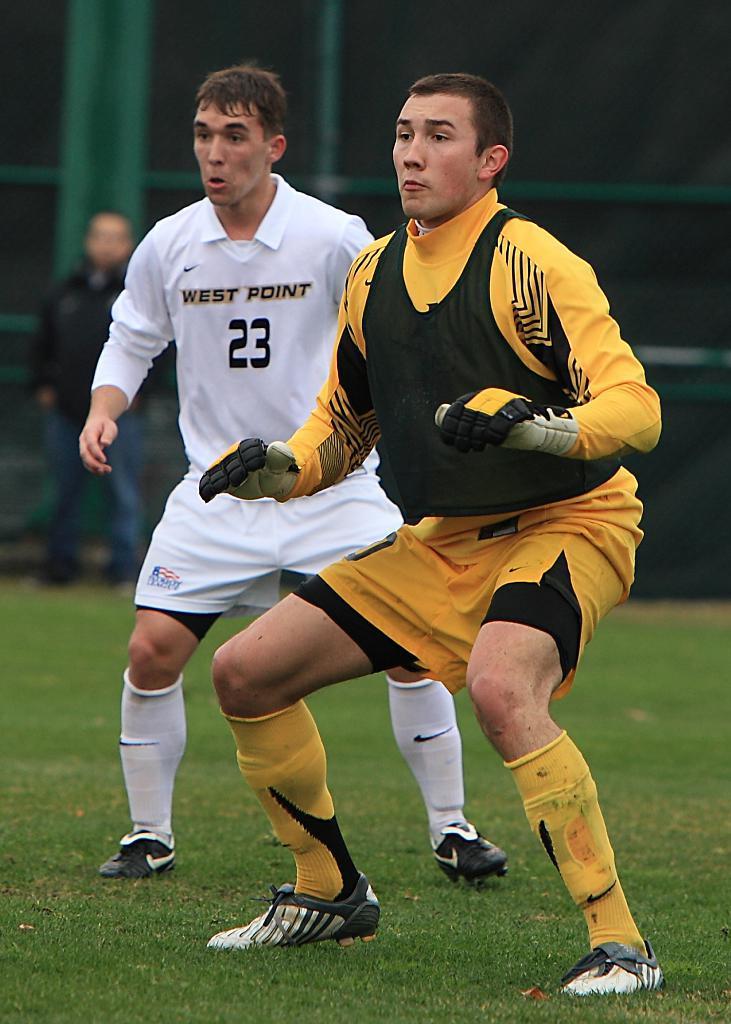Could you give a brief overview of what you see in this image? In this image, we can see people and are wearing sports dress, one of them is wearing gloves. In the background, there are rods and at the bottom, there is ground. 